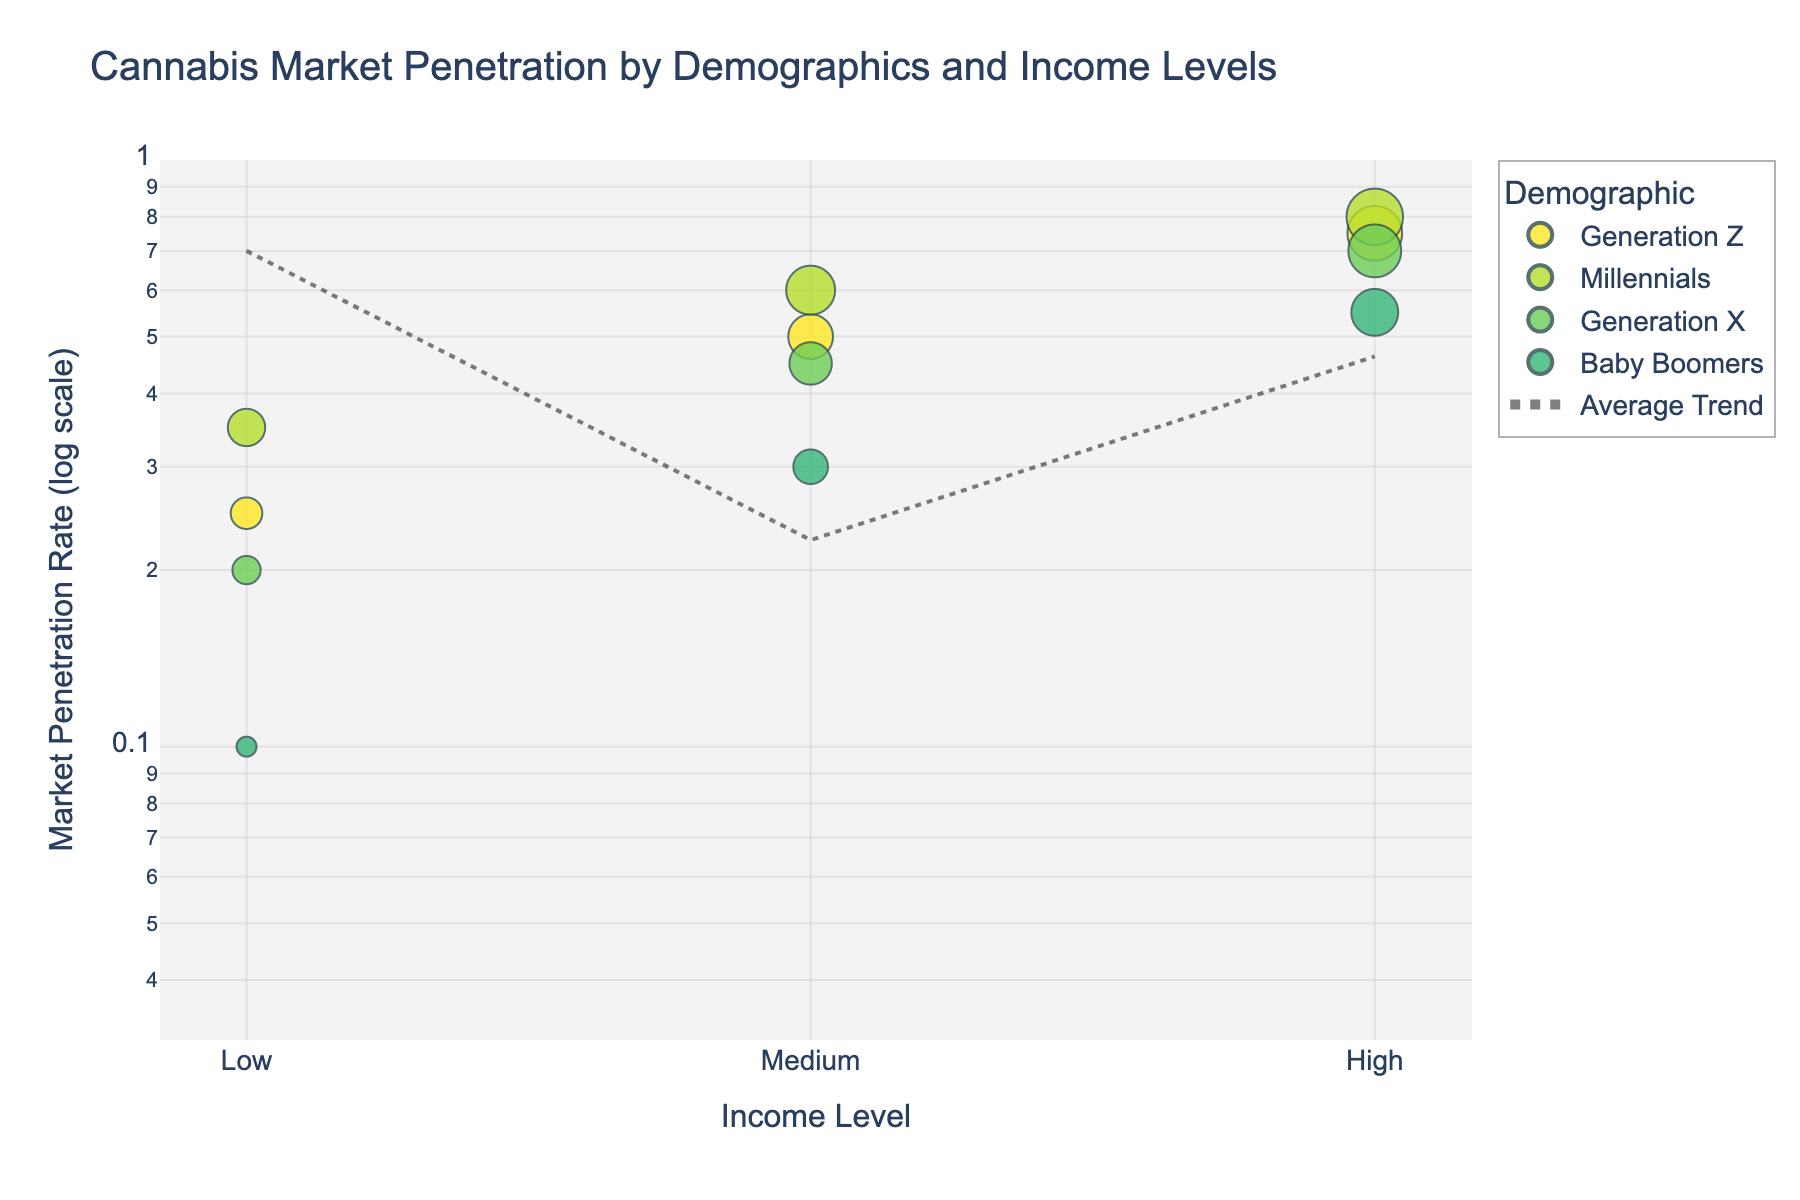What is the title of the figure? The title is typically written at the top of the figure.
Answer: Cannabis Market Penetration by Demographics and Income Levels What are the axis labels for the scatter plot? Axis labels are usually found along the respective axes and indicate what each axis represents. In this case, the x-axis is labeled "Income Level," and the y-axis is labeled "Market Penetration Rate (log scale)."
Answer: Income Level (x-axis) and Market Penetration Rate (log scale) (y-axis) How many demographic categories are represented in the figure? Each unique color corresponds to a different demographic category. The legend shows the demographic categories.
Answer: 4 Which demographic has the highest market penetration rate at the "High" income level? Look at the data points in the "High" income level section and identify the one with the highest market penetration rate.
Answer: Millennials What is the market penetration rate for Baby Boomers at the "Medium" income level? Locate the data point that corresponds to Baby Boomers and the "Medium" income level, then read the market penetration rate from the y-axis.
Answer: 0.30 Compare the market penetration rates of Generation Z and Baby Boomers at the "Low" income level. Which is higher? Locate the data points for Generation Z and Baby Boomers at the "Low" income level and compare their y-axis values.
Answer: Generation Z What is the trend line showing with respect to income levels? Look at the trend line added to the figure and describe the general direction it takes across the different income levels.
Answer: Increasing trend Calculate the average market penetration rate for the "High" income level. Find the "High" income level data points for all demographics, sum their market penetration rates, and divide by the number of points (0.75 + 0.80 + 0.70 + 0.55) / 4.
Answer: 0.70 What is the color scale used in the figure? The color scale is typically indicated in the legend or from the context of the plot. Here, it uses a specific scale from the Viridis color scheme.
Answer: Viridis (reversed) Is there a demographic group that shows significant change in market penetration from "Low" to "High" income levels? Identify it. Compare the market penetration values for each demographic at "Low" and "High" income levels. Identify the group with the largest difference. In this case, calculate for each group.
Answer: Generation Z (0.75 - 0.25 = 0.50 increase) 